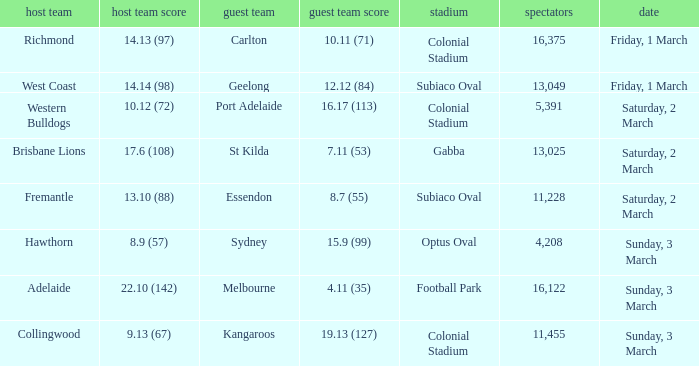When was the away team geelong? Friday, 1 March. 